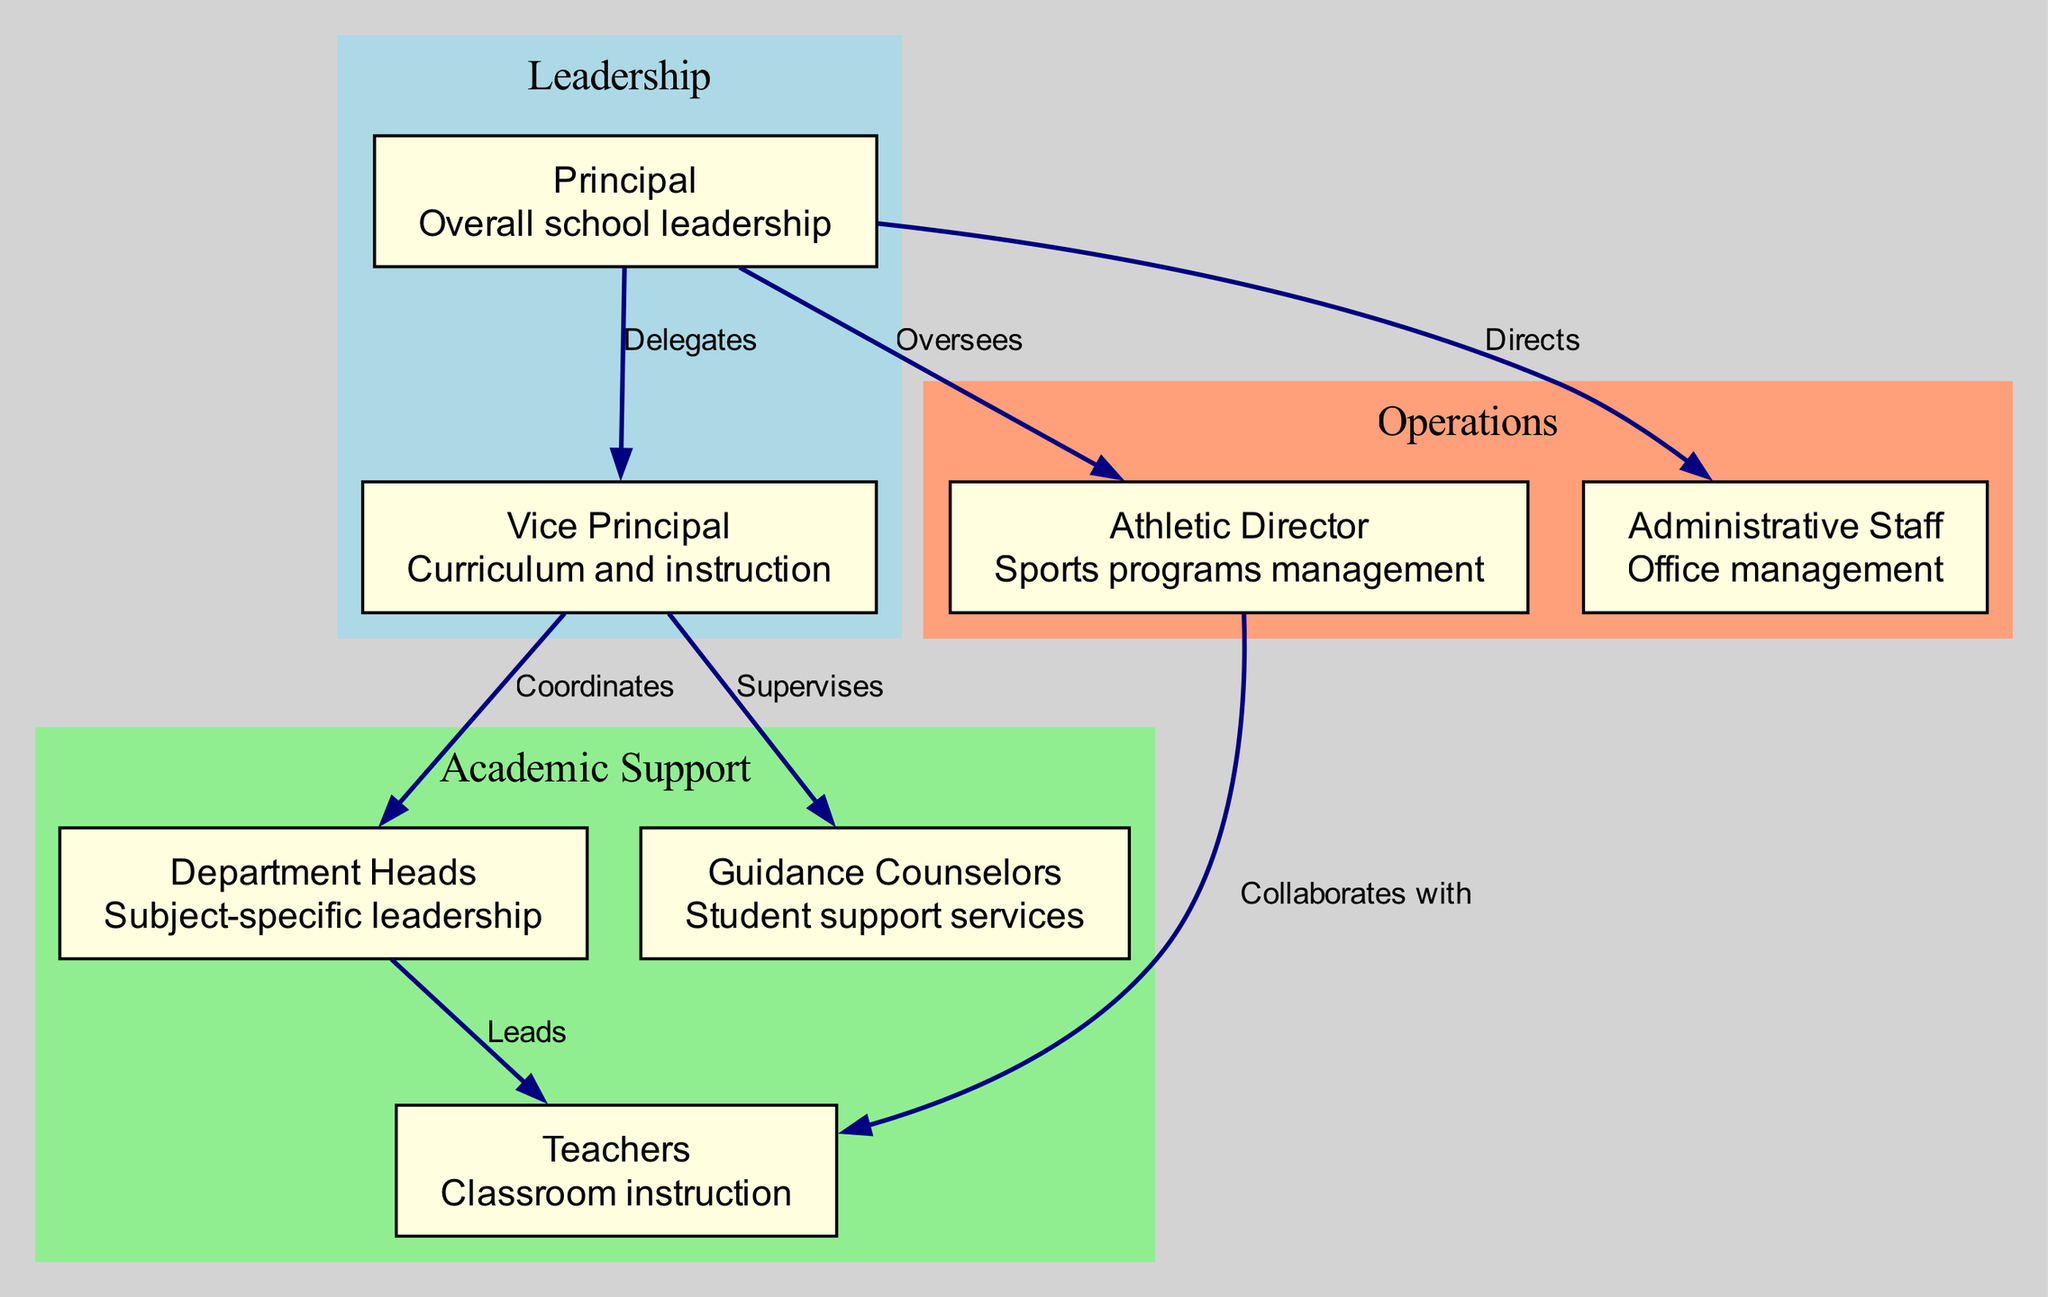What is the top node in the diagram? The top node represents the highest position in the organizational hierarchy, which is the Principal.
Answer: Principal How many nodes are present in the diagram? To find the number of nodes, count each unique role represented in the organizational structure, resulting in a total of 7 nodes.
Answer: 7 What role does the Vice Principal coordinate with? The Vice Principal coordinates with the Department Heads, as indicated by a direct edge from the Vice Principal to this role.
Answer: Department Heads What is the relationship between the Principal and the Athletic Director? The relationship shown is that the Principal oversees the Athletic Director, indicated by a directed edge from the Principal to the Athletic Director labeled as "Oversees".
Answer: Oversees Which role is responsible for student support services? The role responsible for student support services is represented by Guidance Counselors, who provide services to assist students academically and emotionally.
Answer: Guidance Counselors What color represents the Leadership cluster in the diagram? The Leadership cluster is indicated in light blue, as per the subgraph color coding in the diagram.
Answer: Light blue Which two roles directly collaborate with teachers? Teachers are directly collaborated with by Department Heads and the Athletic Director, as shown by the respective edges leading to the Teachers node.
Answer: Department Heads and Athletic Director How many edges are there in the diagram? Counting all the connections between nodes reveals there are 7 edges describing the relationships between various roles.
Answer: 7 What is the description of the role of the Administrative Staff? The Administrative Staff is responsible for office management, handling the internal operations of the school's administrative processes.
Answer: Office management What does the Vice Principal supervise? The Vice Principal supervises the Guidance Counselors, as indicated by the direct edge from the Vice Principal to the Guidance Counselors with the label "Supervises".
Answer: Guidance Counselors 